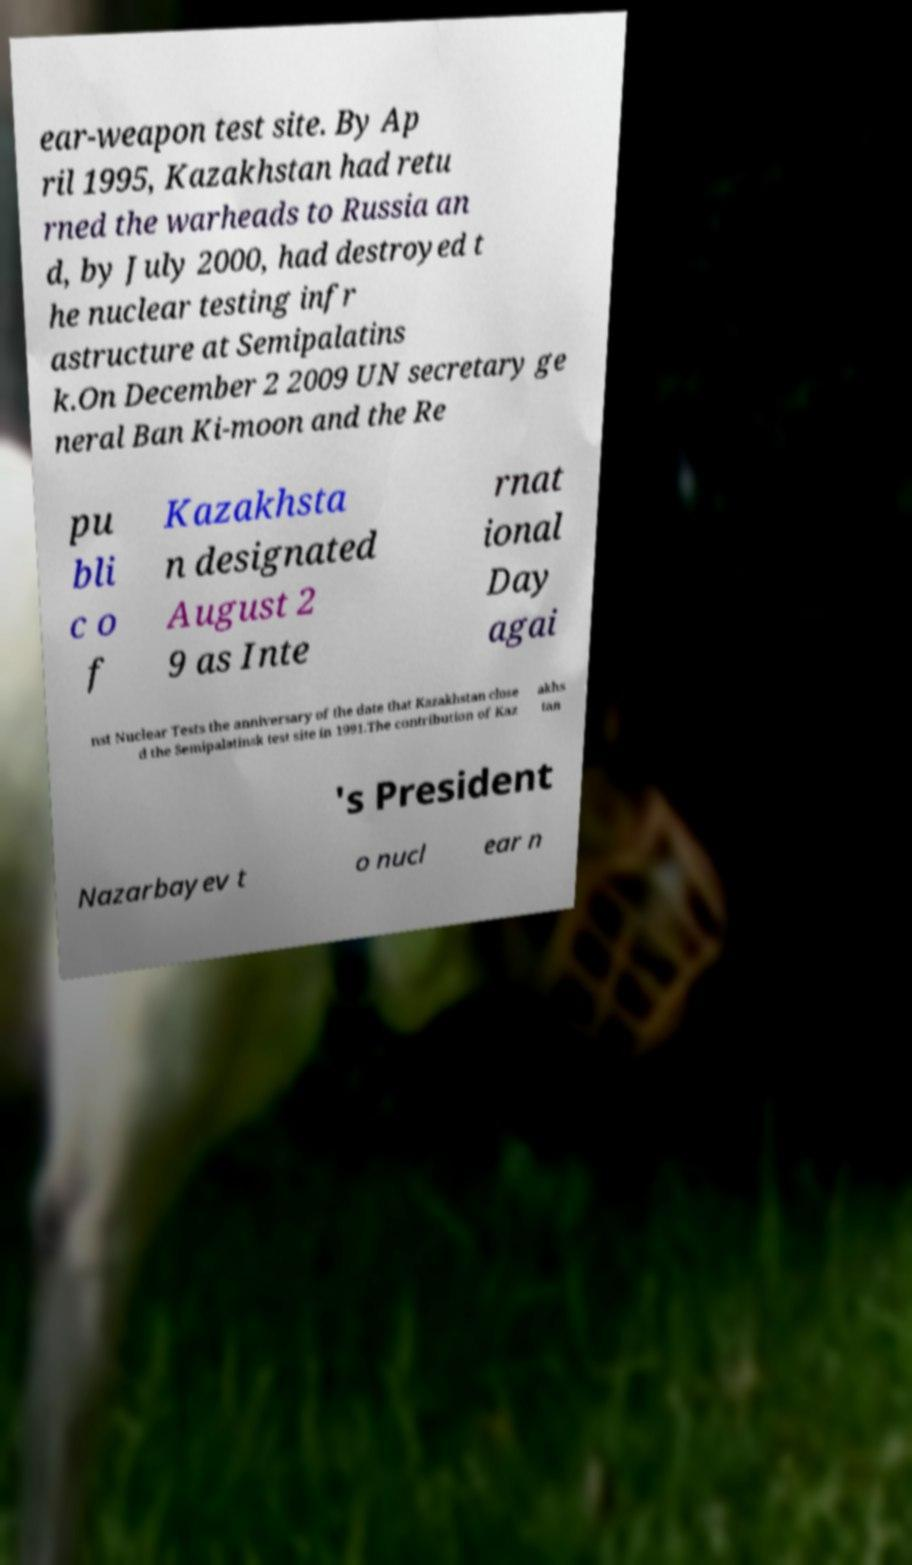I need the written content from this picture converted into text. Can you do that? ear-weapon test site. By Ap ril 1995, Kazakhstan had retu rned the warheads to Russia an d, by July 2000, had destroyed t he nuclear testing infr astructure at Semipalatins k.On December 2 2009 UN secretary ge neral Ban Ki-moon and the Re pu bli c o f Kazakhsta n designated August 2 9 as Inte rnat ional Day agai nst Nuclear Tests the anniversary of the date that Kazakhstan close d the Semipalatinsk test site in 1991.The contribution of Kaz akhs tan 's President Nazarbayev t o nucl ear n 